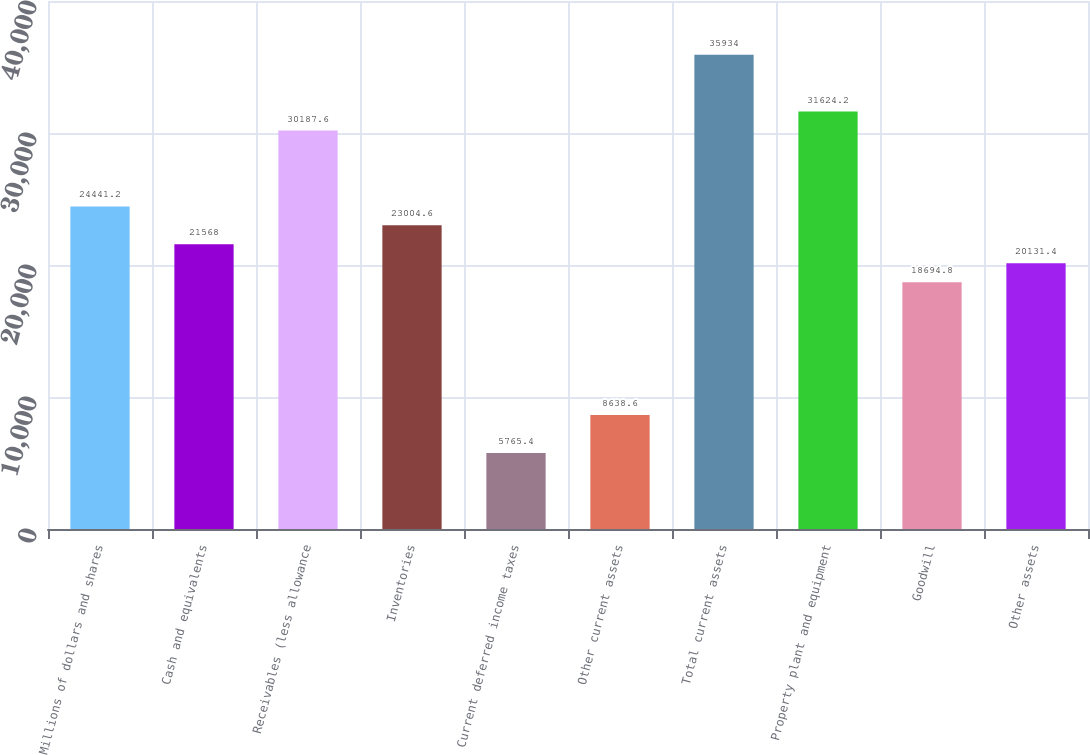Convert chart. <chart><loc_0><loc_0><loc_500><loc_500><bar_chart><fcel>Millions of dollars and shares<fcel>Cash and equivalents<fcel>Receivables (less allowance<fcel>Inventories<fcel>Current deferred income taxes<fcel>Other current assets<fcel>Total current assets<fcel>Property plant and equipment<fcel>Goodwill<fcel>Other assets<nl><fcel>24441.2<fcel>21568<fcel>30187.6<fcel>23004.6<fcel>5765.4<fcel>8638.6<fcel>35934<fcel>31624.2<fcel>18694.8<fcel>20131.4<nl></chart> 